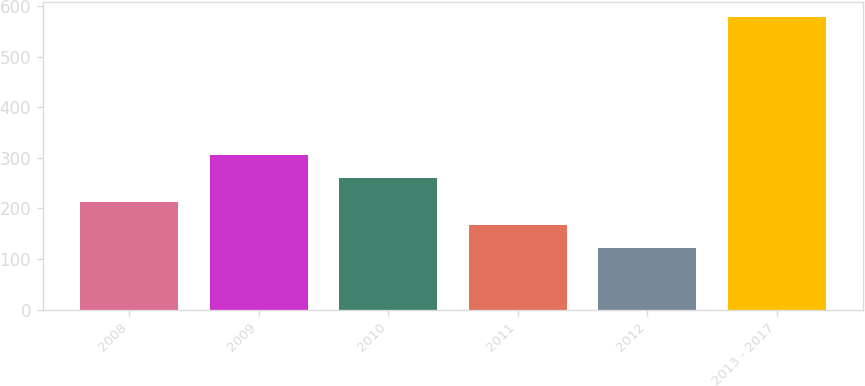Convert chart. <chart><loc_0><loc_0><loc_500><loc_500><bar_chart><fcel>2008<fcel>2009<fcel>2010<fcel>2011<fcel>2012<fcel>2013 - 2017<nl><fcel>213.4<fcel>304.8<fcel>259.1<fcel>167.7<fcel>122<fcel>579<nl></chart> 